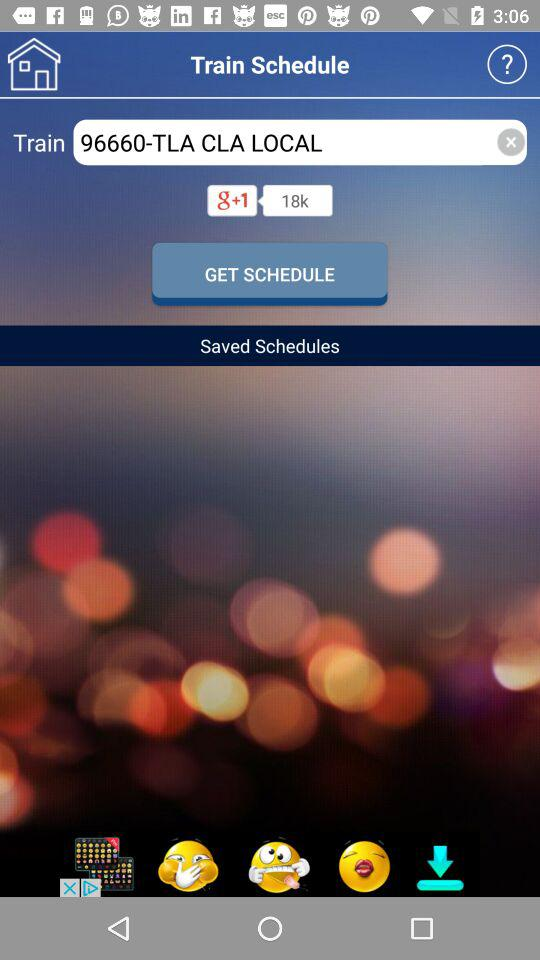What is the train number? The train number is 96660. 